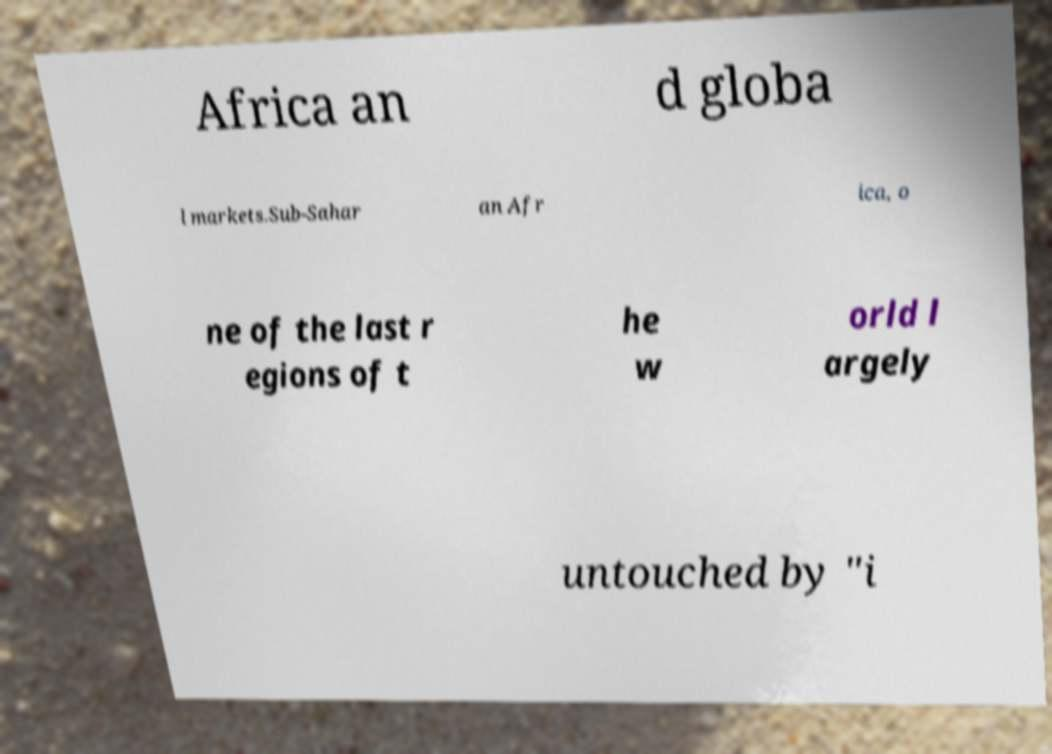There's text embedded in this image that I need extracted. Can you transcribe it verbatim? Africa an d globa l markets.Sub-Sahar an Afr ica, o ne of the last r egions of t he w orld l argely untouched by "i 